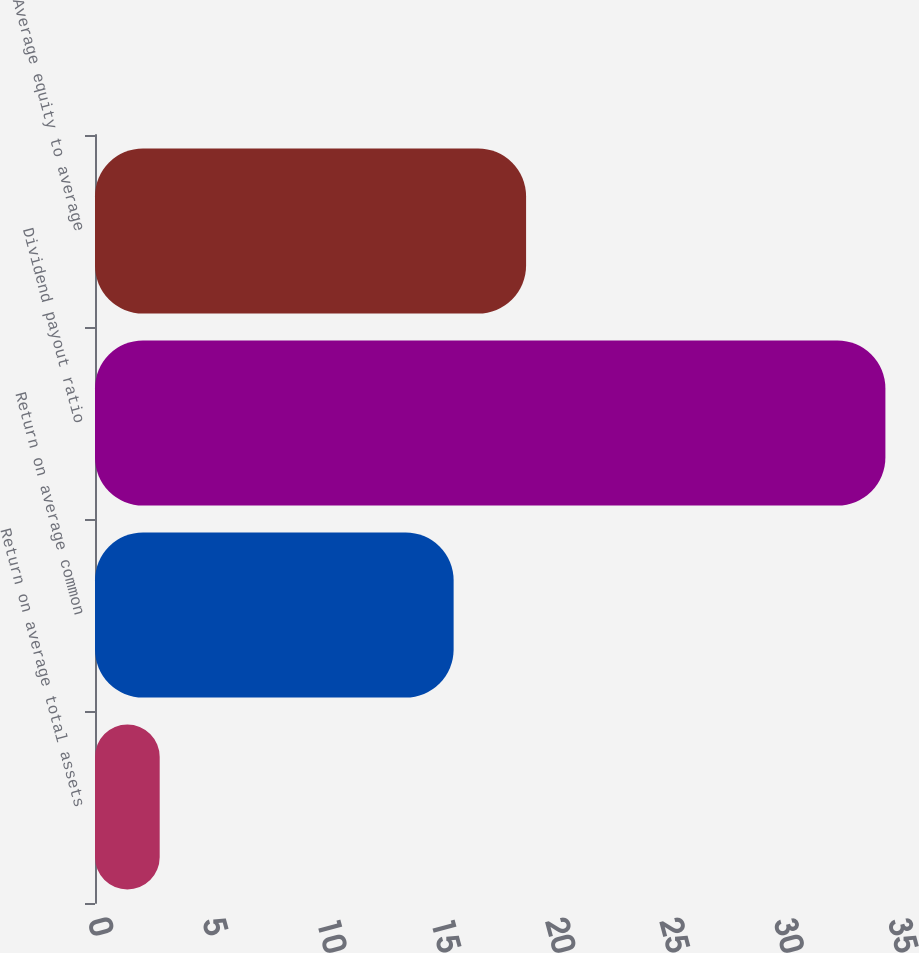Convert chart. <chart><loc_0><loc_0><loc_500><loc_500><bar_chart><fcel>Return on average total assets<fcel>Return on average common<fcel>Dividend payout ratio<fcel>Average equity to average<nl><fcel>2.83<fcel>15.69<fcel>34.58<fcel>18.86<nl></chart> 